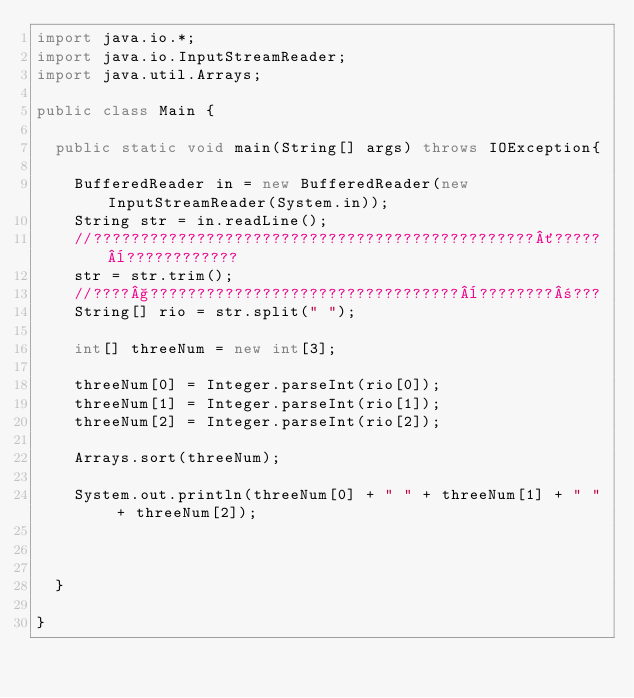<code> <loc_0><loc_0><loc_500><loc_500><_Java_>import java.io.*;
import java.io.InputStreamReader;
import java.util.Arrays;

public class Main {
	
	public static void main(String[] args) throws IOException{
		
		BufferedReader in = new BufferedReader(new InputStreamReader(System.in));
		String str = in.readLine();
		//???????????????????????????????????????????????´?????¨????????????
		str = str.trim();
		//????§?????????????????????????????????¨????????±???
		String[] rio = str.split(" ");
		
		int[] threeNum = new int[3];
		
		threeNum[0] = Integer.parseInt(rio[0]);
		threeNum[1] = Integer.parseInt(rio[1]);
		threeNum[2] = Integer.parseInt(rio[2]);
		
		Arrays.sort(threeNum);
		
		System.out.println(threeNum[0] + " " + threeNum[1] + " " + threeNum[2]);
		
		
		
	}

}</code> 